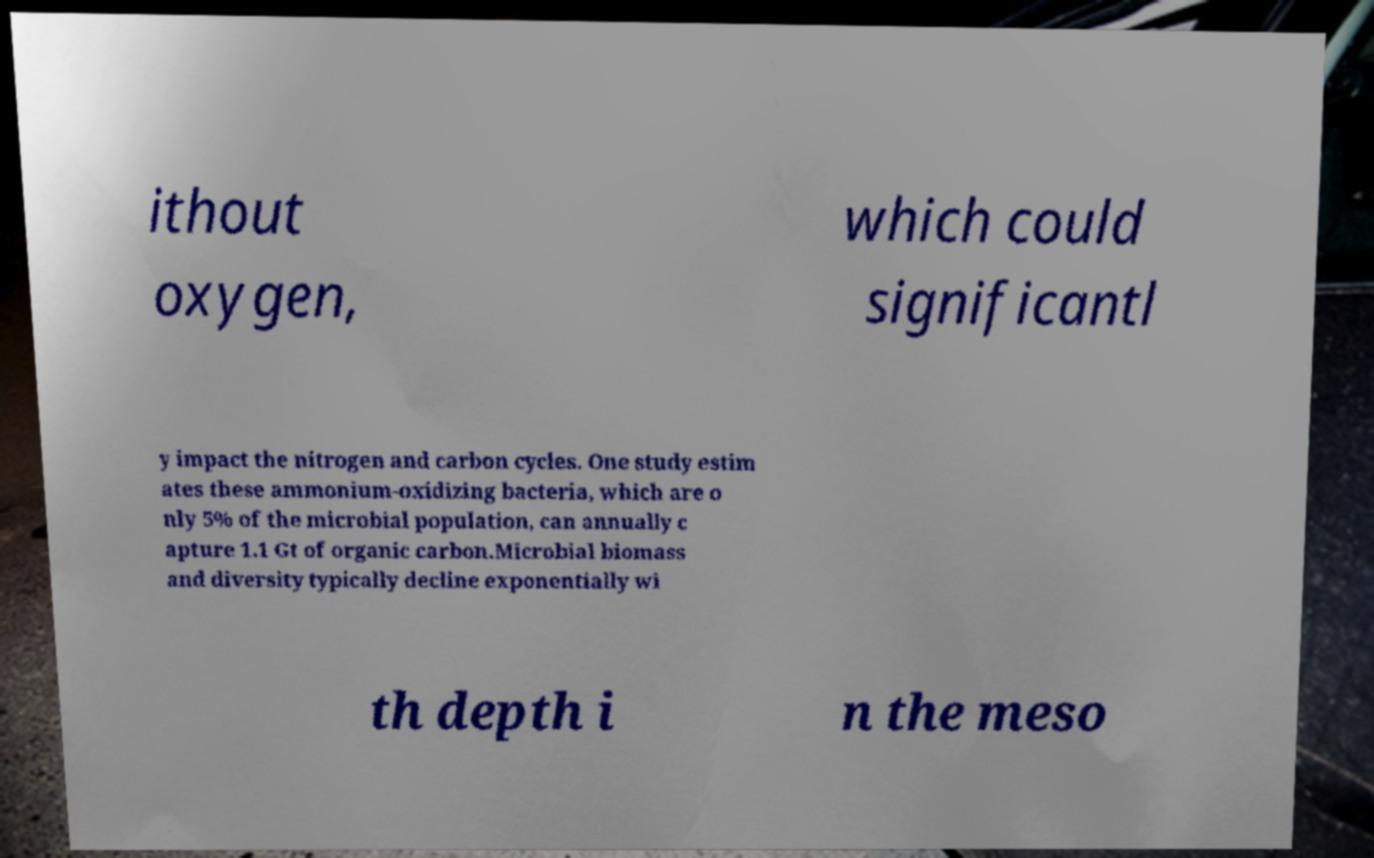There's text embedded in this image that I need extracted. Can you transcribe it verbatim? ithout oxygen, which could significantl y impact the nitrogen and carbon cycles. One study estim ates these ammonium-oxidizing bacteria, which are o nly 5% of the microbial population, can annually c apture 1.1 Gt of organic carbon.Microbial biomass and diversity typically decline exponentially wi th depth i n the meso 